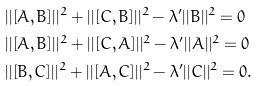Convert formula to latex. <formula><loc_0><loc_0><loc_500><loc_500>& | | [ A , B ] | | ^ { 2 } + | | [ C , B ] | | ^ { 2 } - \lambda ^ { \prime } | | B | | ^ { 2 } = 0 \\ & | | [ A , B ] | | ^ { 2 } + | | [ C , A ] | | ^ { 2 } - \lambda ^ { \prime } | | A | | ^ { 2 } = 0 \\ & | | [ B , C ] | | ^ { 2 } + | | [ A , C ] | | ^ { 2 } - \lambda ^ { \prime } | | C | | ^ { 2 } = 0 .</formula> 